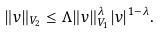Convert formula to latex. <formula><loc_0><loc_0><loc_500><loc_500>\| v \| _ { V _ { 2 } } \leq \Lambda \| v \| _ { V _ { 1 } } ^ { \lambda } | v | ^ { 1 - \lambda } .</formula> 